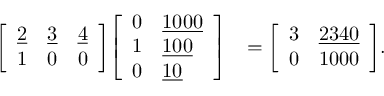Convert formula to latex. <formula><loc_0><loc_0><loc_500><loc_500>{ \begin{array} { r l } { { \left [ \begin{array} { l l l } { { \underline { 2 } } } & { { \underline { 3 } } } & { { \underline { 4 } } } \\ { 1 } & { 0 } & { 0 } \end{array} \right ] } { \left [ \begin{array} { l l } { 0 } & { { \underline { 1 0 0 0 } } } \\ { 1 } & { { \underline { 1 0 0 } } } \\ { 0 } & { { \underline { 1 0 } } } \end{array} \right ] } } & { = { \left [ \begin{array} { l l } { 3 } & { { \underline { 2 3 4 0 } } } \\ { 0 } & { 1 0 0 0 } \end{array} \right ] } . } \end{array} }</formula> 